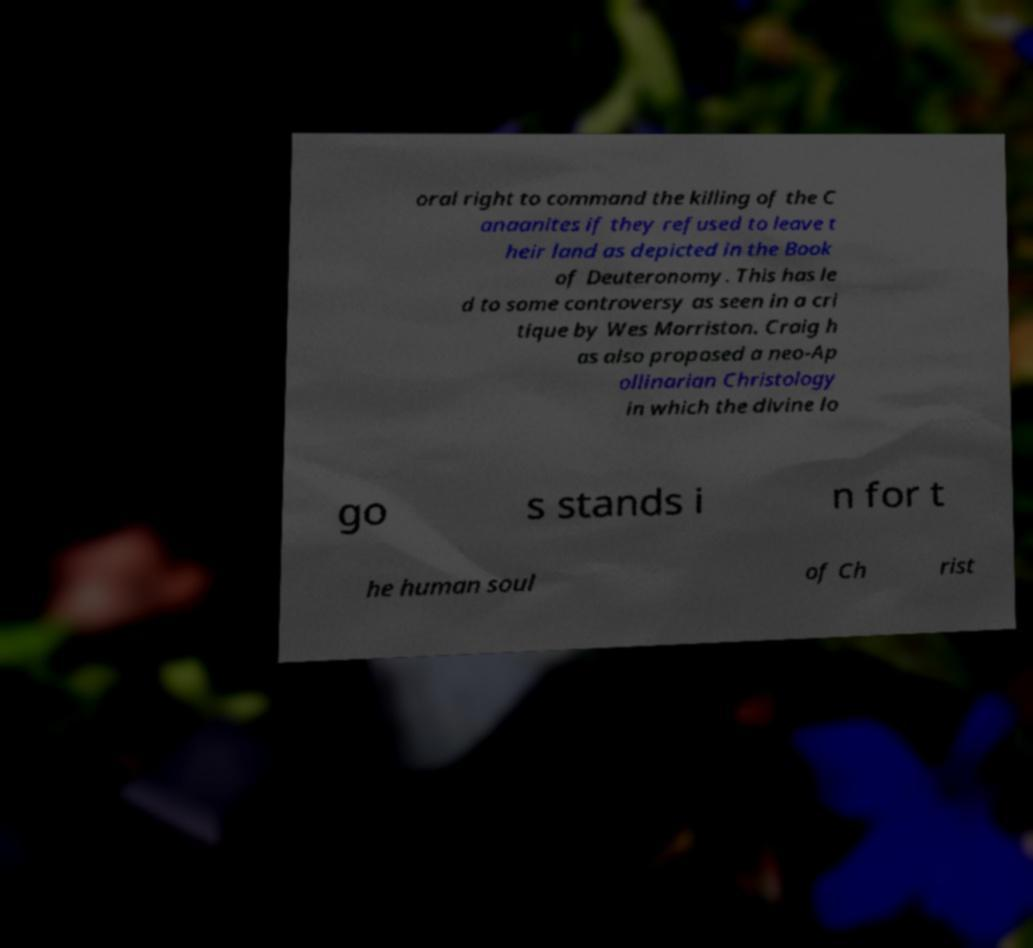Could you extract and type out the text from this image? oral right to command the killing of the C anaanites if they refused to leave t heir land as depicted in the Book of Deuteronomy. This has le d to some controversy as seen in a cri tique by Wes Morriston. Craig h as also proposed a neo-Ap ollinarian Christology in which the divine lo go s stands i n for t he human soul of Ch rist 